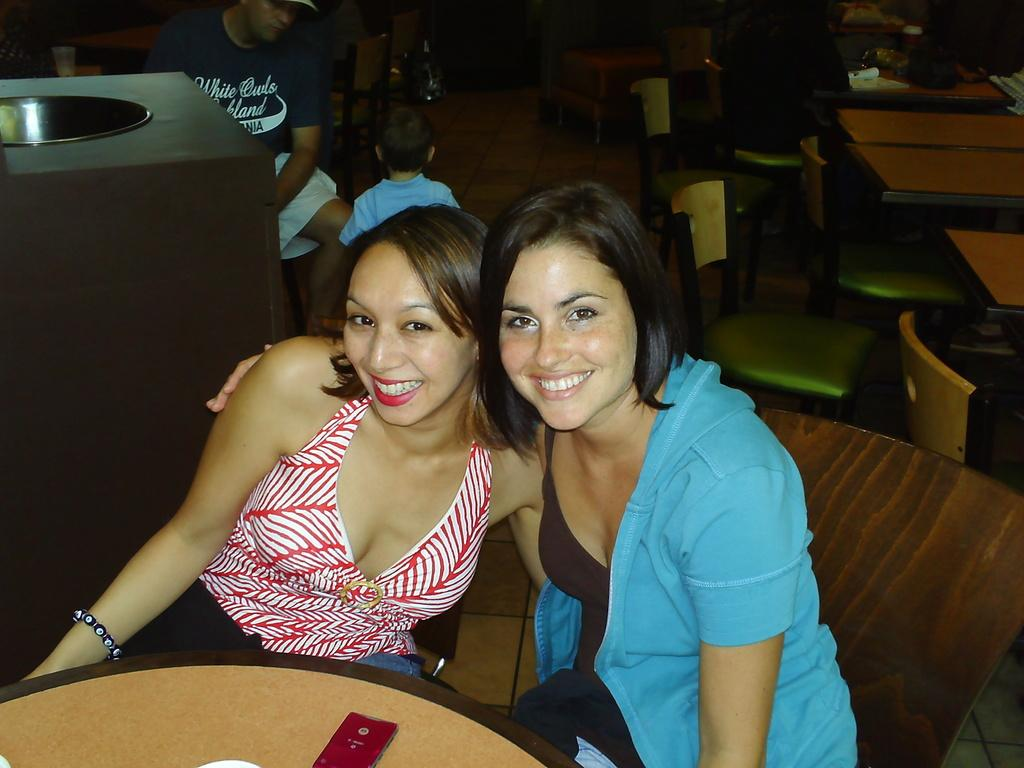Who are the main subjects in the image? There are two ladies in the center of the image. What is the ladies' facial expression? The ladies are smiling. What is located in front of the ladies? There is a table before the ladies. Can you describe the background of the image? There is a man and a kid in the background of the image, and there are tables and chairs visible. What is the owner of the table pointing at in the image? There is no owner of the table present in the image, and no one is pointing at anything. What type of trade is being conducted in the image? There is no trade being conducted in the image; it features two ladies smiling and a table in front of them. 